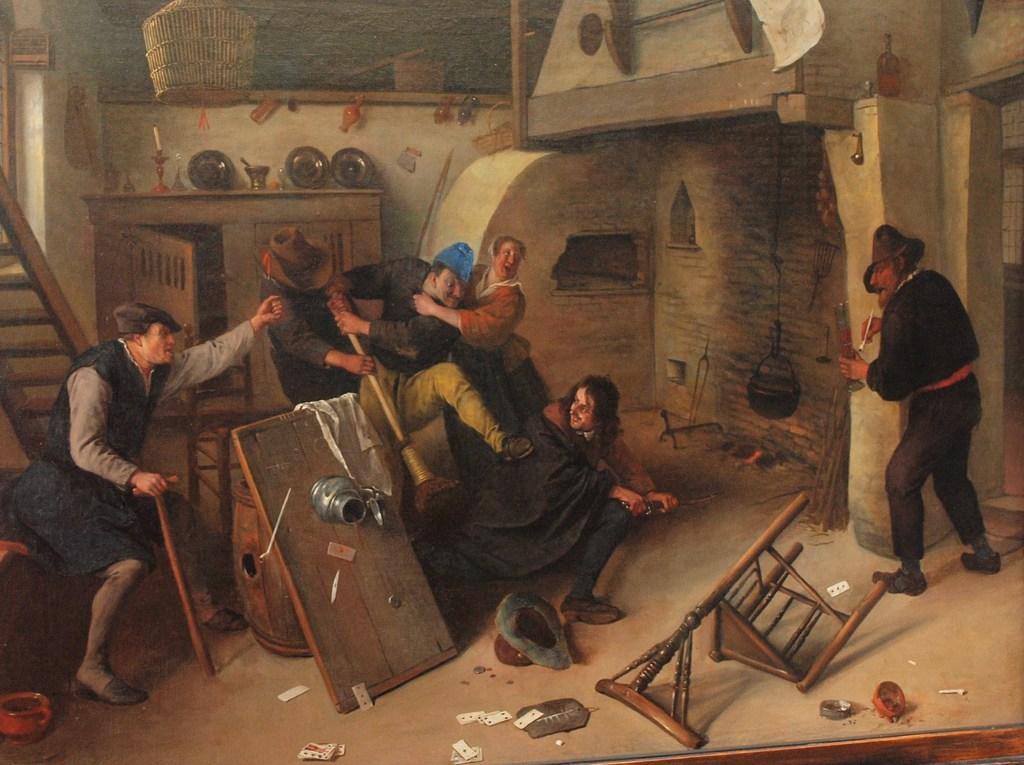Could you give a brief overview of what you see in this image? This image is a photo frame. In the center of the image there are people. In the background of the image there is wall. there is a cupboard on which there are many objects. At the bottom of the image there are many objects. 